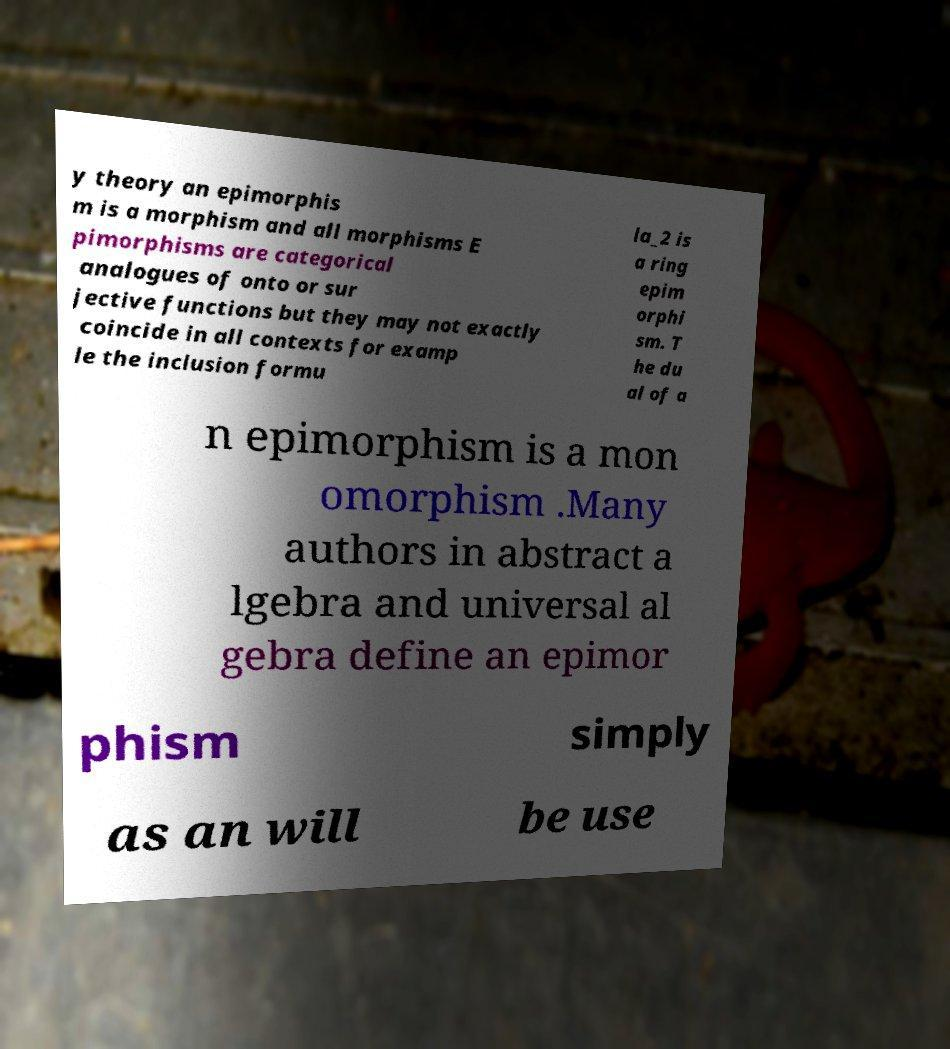Could you assist in decoding the text presented in this image and type it out clearly? y theory an epimorphis m is a morphism and all morphisms E pimorphisms are categorical analogues of onto or sur jective functions but they may not exactly coincide in all contexts for examp le the inclusion formu la_2 is a ring epim orphi sm. T he du al of a n epimorphism is a mon omorphism .Many authors in abstract a lgebra and universal al gebra define an epimor phism simply as an will be use 